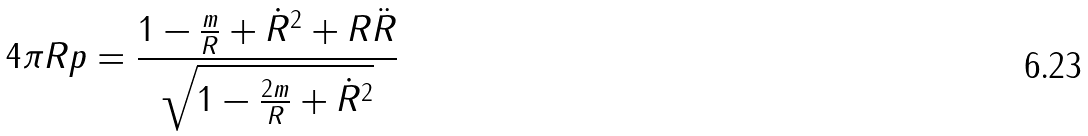Convert formula to latex. <formula><loc_0><loc_0><loc_500><loc_500>4 \pi R p = \frac { 1 - \frac { m } { R } + \dot { R } ^ { 2 } + R \ddot { R } } { \sqrt { 1 - \frac { 2 m } { R } + \dot { R } ^ { 2 } } }</formula> 